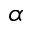<formula> <loc_0><loc_0><loc_500><loc_500>\alpha</formula> 